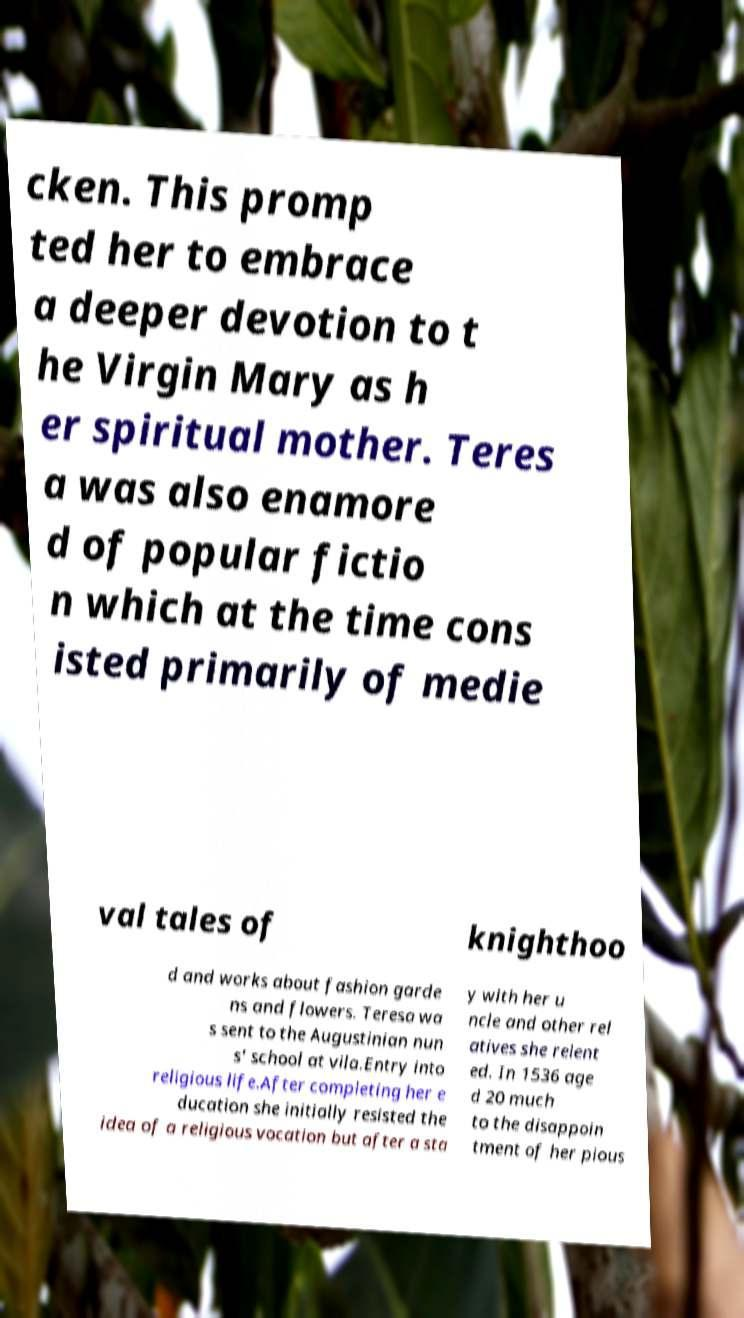For documentation purposes, I need the text within this image transcribed. Could you provide that? cken. This promp ted her to embrace a deeper devotion to t he Virgin Mary as h er spiritual mother. Teres a was also enamore d of popular fictio n which at the time cons isted primarily of medie val tales of knighthoo d and works about fashion garde ns and flowers. Teresa wa s sent to the Augustinian nun s' school at vila.Entry into religious life.After completing her e ducation she initially resisted the idea of a religious vocation but after a sta y with her u ncle and other rel atives she relent ed. In 1536 age d 20 much to the disappoin tment of her pious 